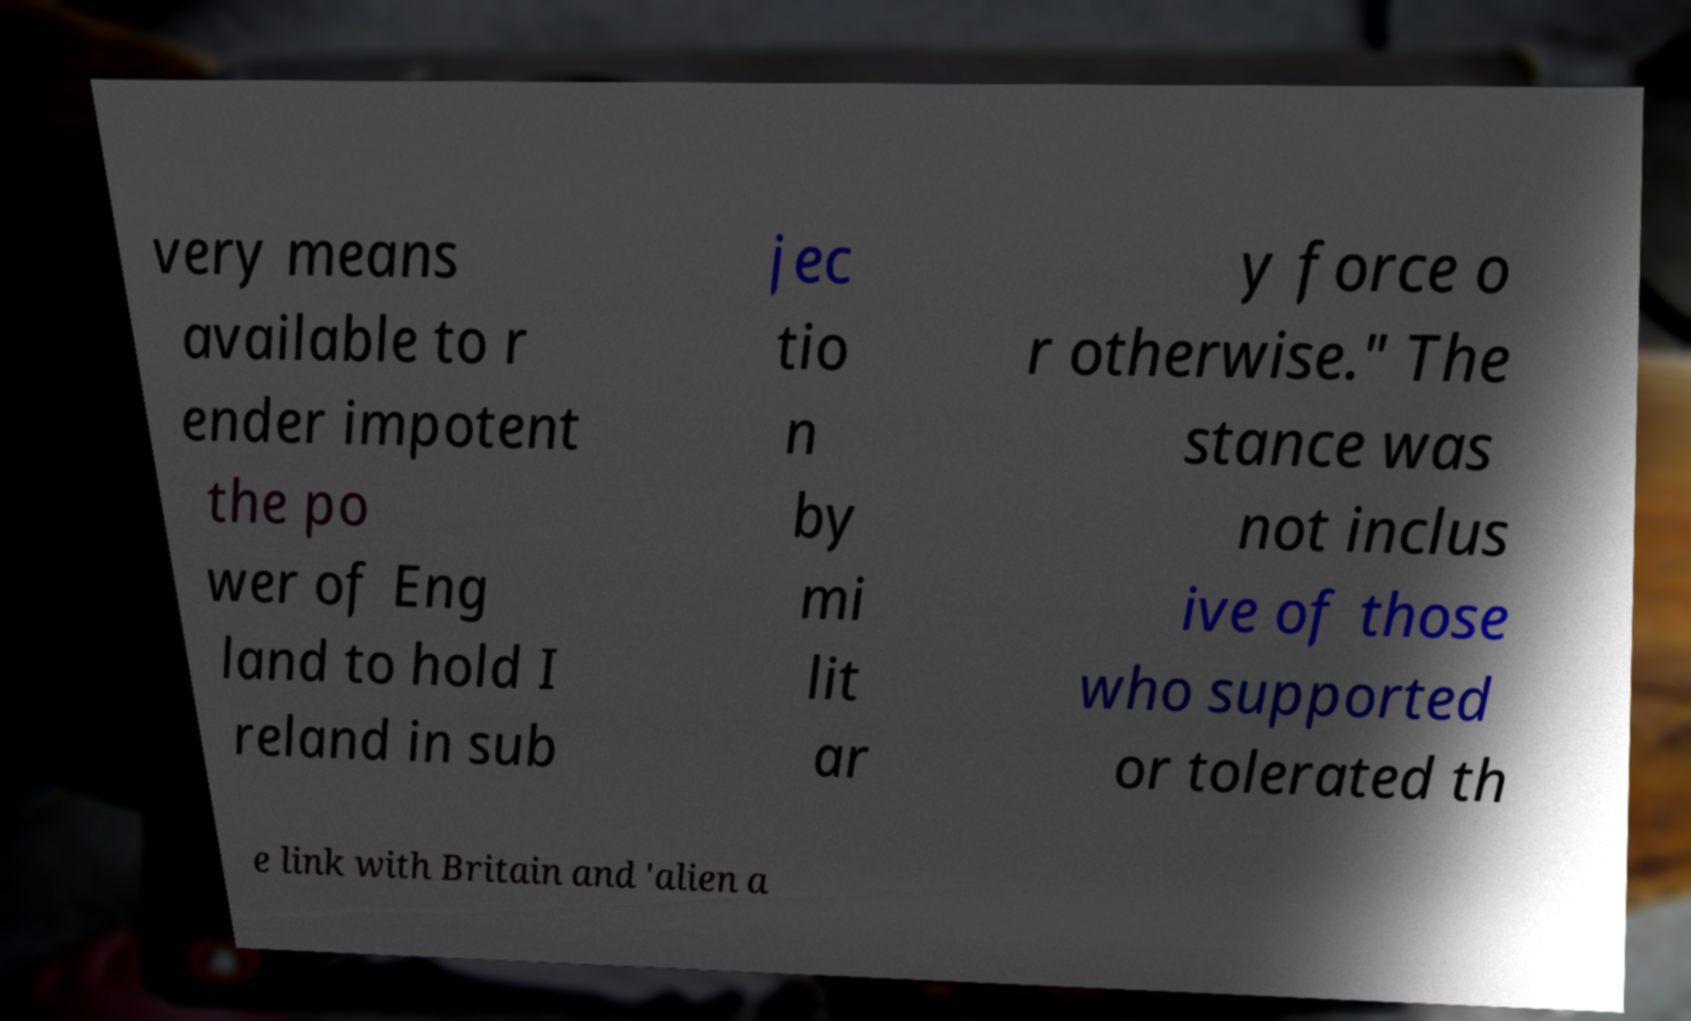Could you extract and type out the text from this image? very means available to r ender impotent the po wer of Eng land to hold I reland in sub jec tio n by mi lit ar y force o r otherwise." The stance was not inclus ive of those who supported or tolerated th e link with Britain and 'alien a 